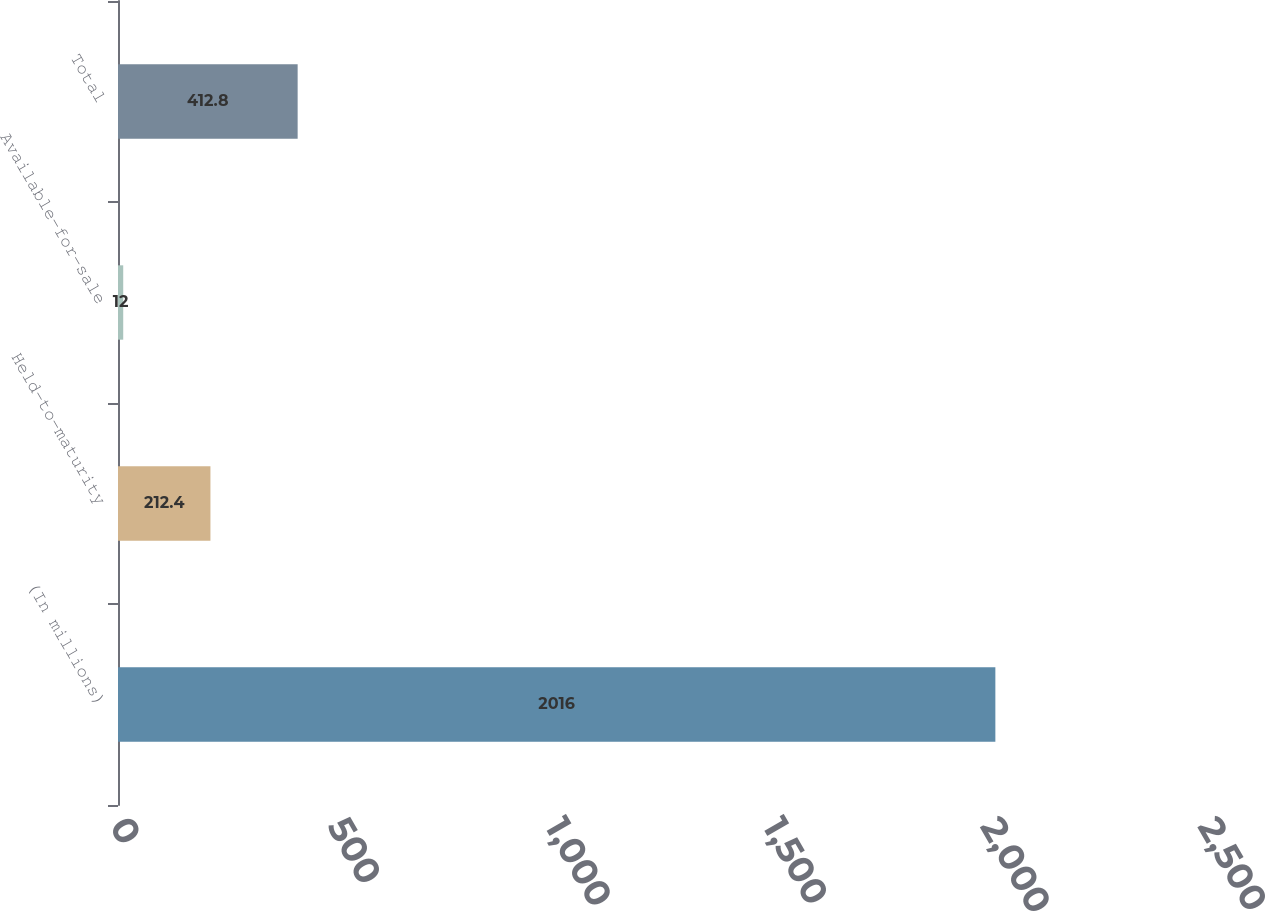Convert chart to OTSL. <chart><loc_0><loc_0><loc_500><loc_500><bar_chart><fcel>(In millions)<fcel>Held-to-maturity<fcel>Available-for-sale<fcel>Total<nl><fcel>2016<fcel>212.4<fcel>12<fcel>412.8<nl></chart> 